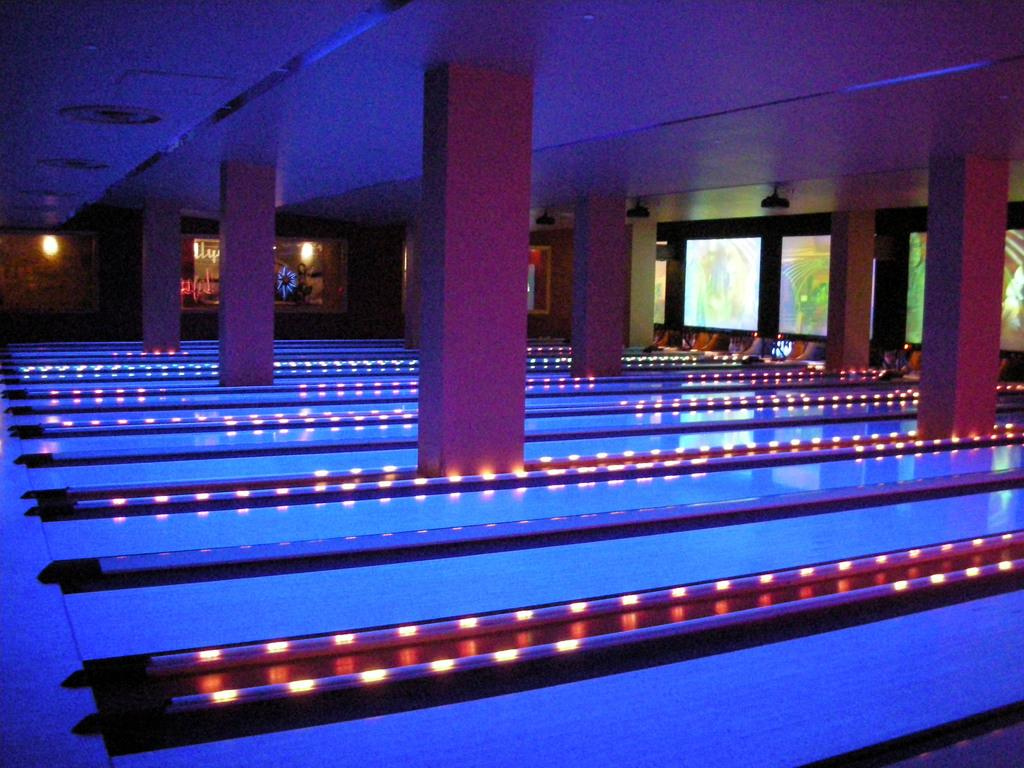What is the main subject of the image? The main subject of the image is bowling trucks. What can be seen in the middle of the image? There are pillars in the middle of the image. What is located at the top of the image? There is a roof at the top of the image. Where are the windows located in the image? The windows are to the right of the image. How many feet are visible in the image? There are no feet visible in the image; it features bowling trucks, pillars, a roof, and windows. 